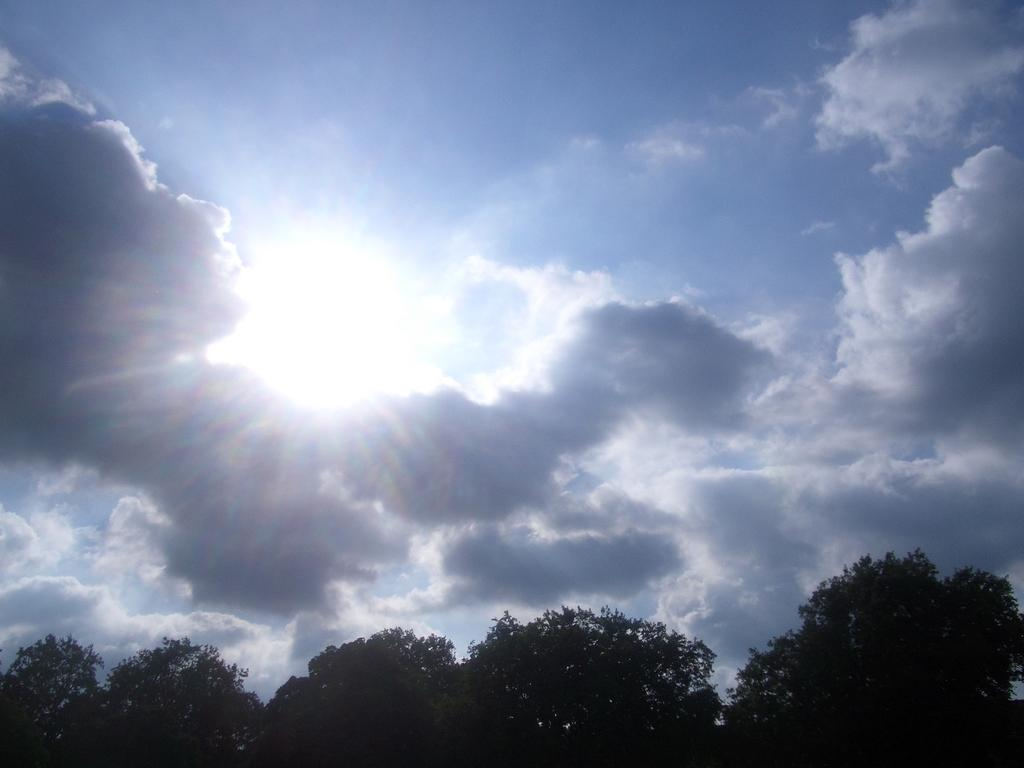What is visible at the top of the image? The sky is visible in the image. What can be seen in the sky? There are clouds visible in the sky. What is the source of light in the image? Sunlight is present in the image. What type of vegetation is visible at the bottom of the image? Trees are visible at the bottom of the image. What type of knife is being used to adjust the acoustics in the image? There is no knife or adjustment of acoustics present in the image. 